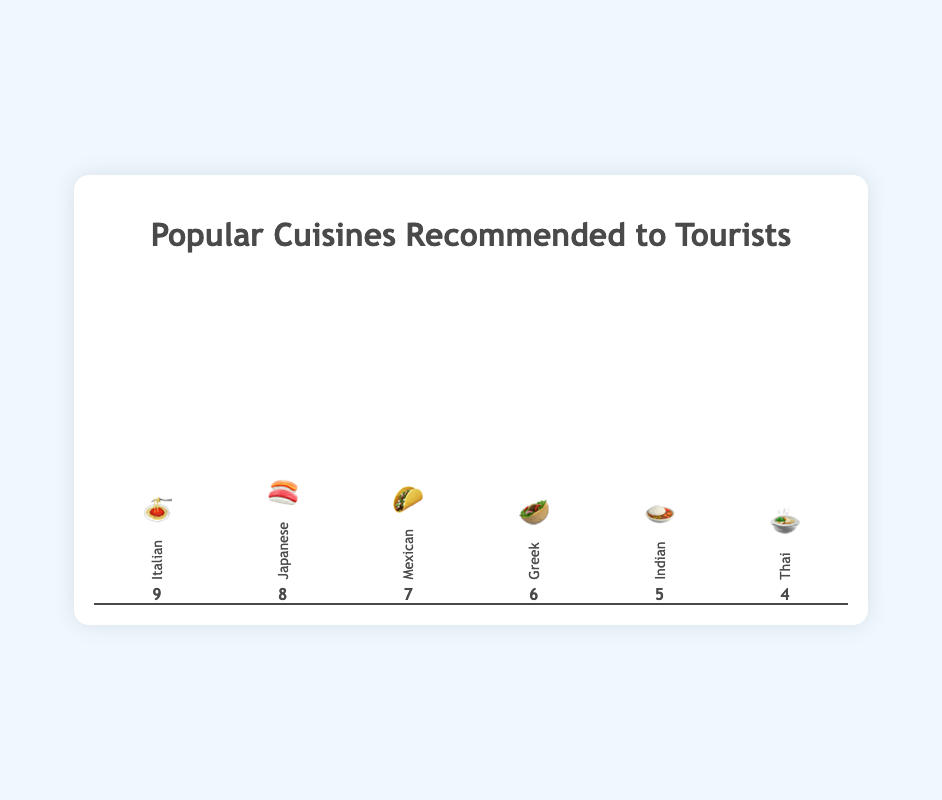What is the highest recommended cuisine? The highest recommended cuisine can be identified by the tallest bar in the figure. The Italian cuisine represented by the 🍝 emoji has the tallest bar with a score of 9.
Answer: Italian 🍝 Which cuisine has a recommendation score of 6? To find the cuisine with a score of 6, look for the bar with a height indicating that score. The Greek cuisine, represented by the 🥙 emoji, has a score of 6.
Answer: Greek 🥙 How many cuisines have a recommendation score higher than 6? Count the bars with heights greater than the one with a score of 6. Italian 🍝 and Japanese 🍣 cuisines have scores higher than 6.
Answer: 2 Which cuisine has the lowest recommendation score? Identify the shortest bar in the figure and check its cuisine. The Thai cuisine, represented by the 🍲 emoji, has the lowest recommendation score of 4.
Answer: Thai 🍲 What is the combined recommendation score of Mexican and Indian cuisines? Add the recommendation scores of the Mexican and Indian cuisines. Mexican has a score of 7, and Indian has a score of 5. 7 + 5 = 12
Answer: 12 By how much does the recommendation score of Italian cuisine exceed that of Thai cuisine? Subtract the recommendation score of Thai cuisine from the score of Italian cuisine. Italian has 9 and Thai has 4. 9 - 4 = 5
Answer: 5 Are there more cuisines with a recommendation score of 7 or higher than those with less than 7? Count the number of cuisines with scores of 7 or higher (Italian 🍝, Japanese 🍣, Mexican 🌮) and compare with those less than 7 (Greek 🥙, Indian 🍛, Thai 🍲). Both categories have 3 cuisines each.
Answer: No What is the average recommendation score for all the cuisines? Add all the recommendation scores and divide by the number of cuisines. Scores are 9, 8, 7, 6, 5, 4. Total = 39, number of cuisines = 6, so 39/6 = 6.5
Answer: 6.5 Which cuisine's bar is exactly halfway between the highest and lowest recommendation scores? The scores ranging from 4 to 9 have a midpoint of 6.5. The cuisine closest to 6.5 is Greek 🥙 with a score of 6.
Answer: Greek 🥙 